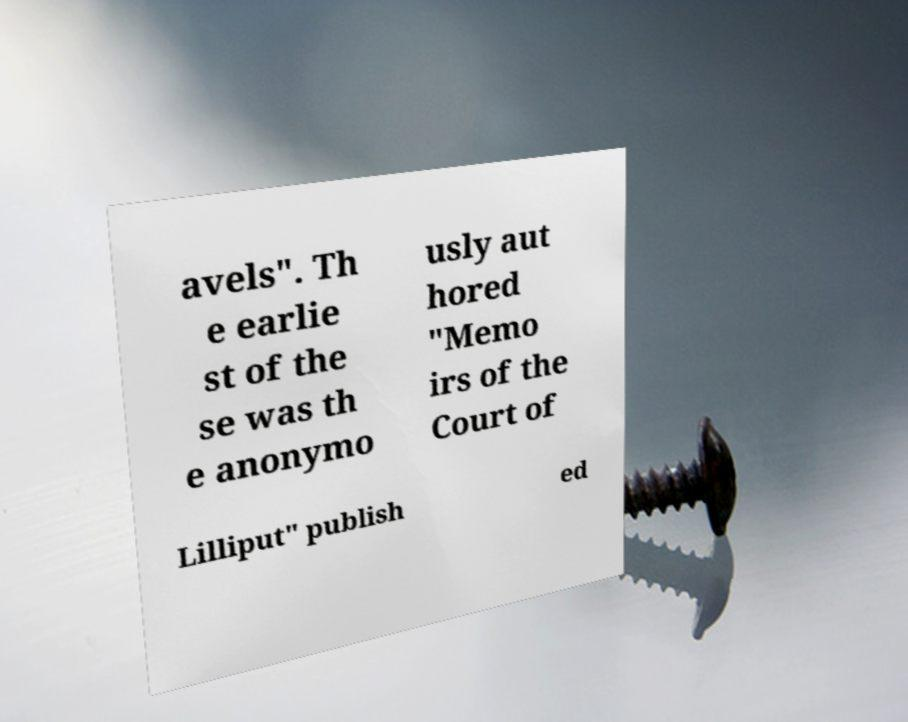Could you assist in decoding the text presented in this image and type it out clearly? avels". Th e earlie st of the se was th e anonymo usly aut hored "Memo irs of the Court of Lilliput" publish ed 